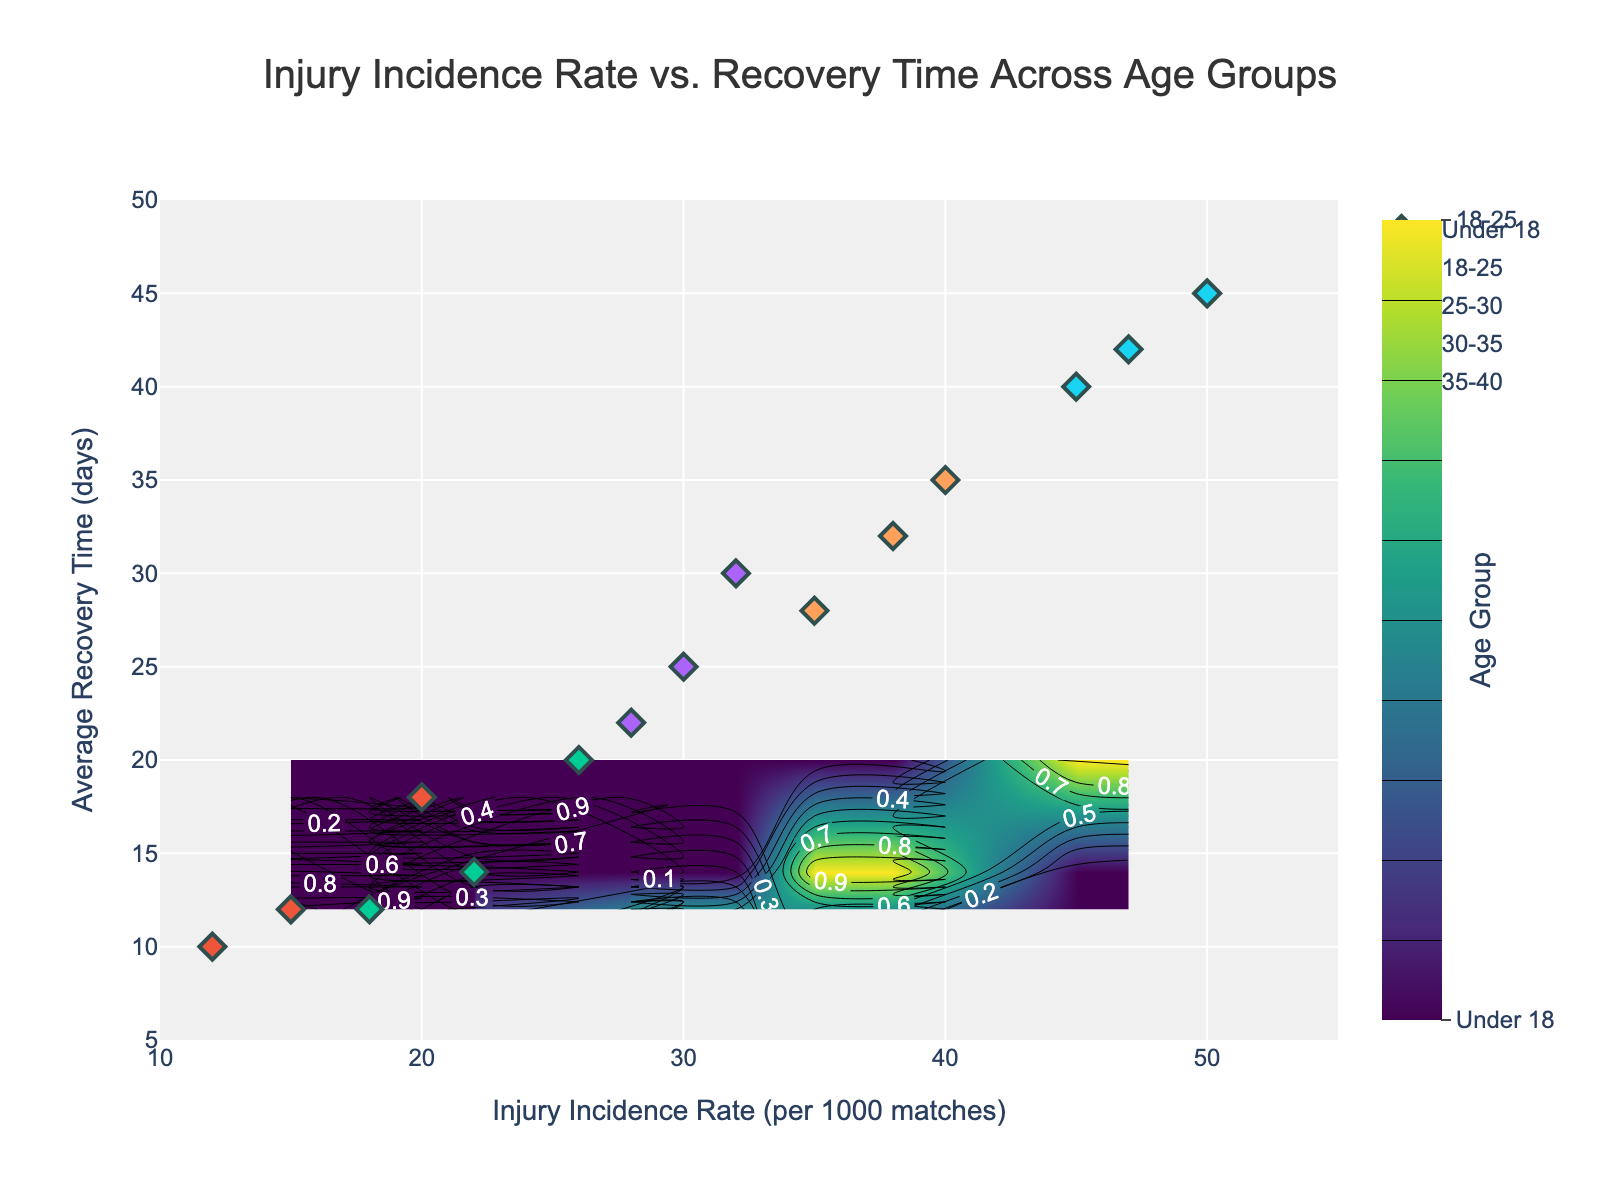What's the title of the figure? The title is generally placed at the top of the plot, and it is clearly written in large font.
Answer: Injury Incidence Rate vs. Recovery Time Across Age Groups What's the range of the x-axis in the figure? The x-axis range is visible along the bottom of the plot, showing the minimum and maximum values.
Answer: 10 to 55 Which age group has the highest average recovery time? By observing the contour plot and the scatter points, the age group with the highest points on the y-axis is identified.
Answer: 35-40 Do younger players (Under 18) generally have lower injury incidence rates compared to older players (30-35)? By comparing the data points for both age groups along the x-axis, we observe that younger players tend to have lower injury incidence rates.
Answer: Yes What's the plot's background color? The background color is typically shown behind all plot elements. In this case, it's a shade that complements the plotted data.
Answer: Light grey Which age group has the most data points in the plot? We can count the number of scatter points (markers) associated with each age group.
Answer: 35-40 How does the recovery time for the 18-25 age group compare to the 25-30 group? By looking at the data points and contours for these two age groups, we can compare their y-axis values. The 25-30 group generally has higher recovery times.
Answer: 25-30 What is the general trend of injury incidence rate with age? By observing the progression of the data points and contour lines from younger to older age groups, we can see whether the incidence rate increases or decreases.
Answer: Increases What's the contour color scheme used in the plot? The color scheme is visible in the contour areas and indicated by the color bar on the side.
Answer: Viridis What is the average recovery time for the 30-35 age group? We see the data points for this age group and find the average y-value of these points. The values are 28, 35, and 32. Average is (28+35+32)/3 = 31.67
Answer: 31.67 